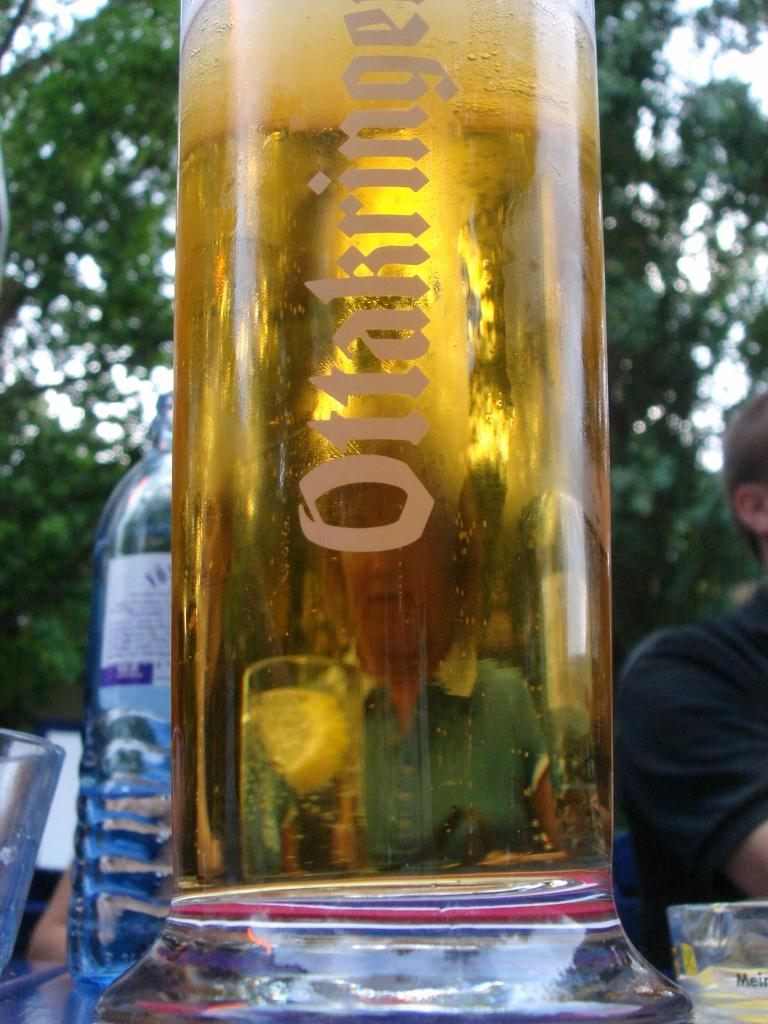What is one object visible in the image? There is a bottle in the image. What is another object visible in the image? There is a glass in the image. What can be seen in the background of the image? There is a tree visible in the background of the image. How many mice are sitting on the bottle in the image? There are no mice present in the image. Can you describe the kiss between the two people in the image? There are no people or kisses depicted in the image. 